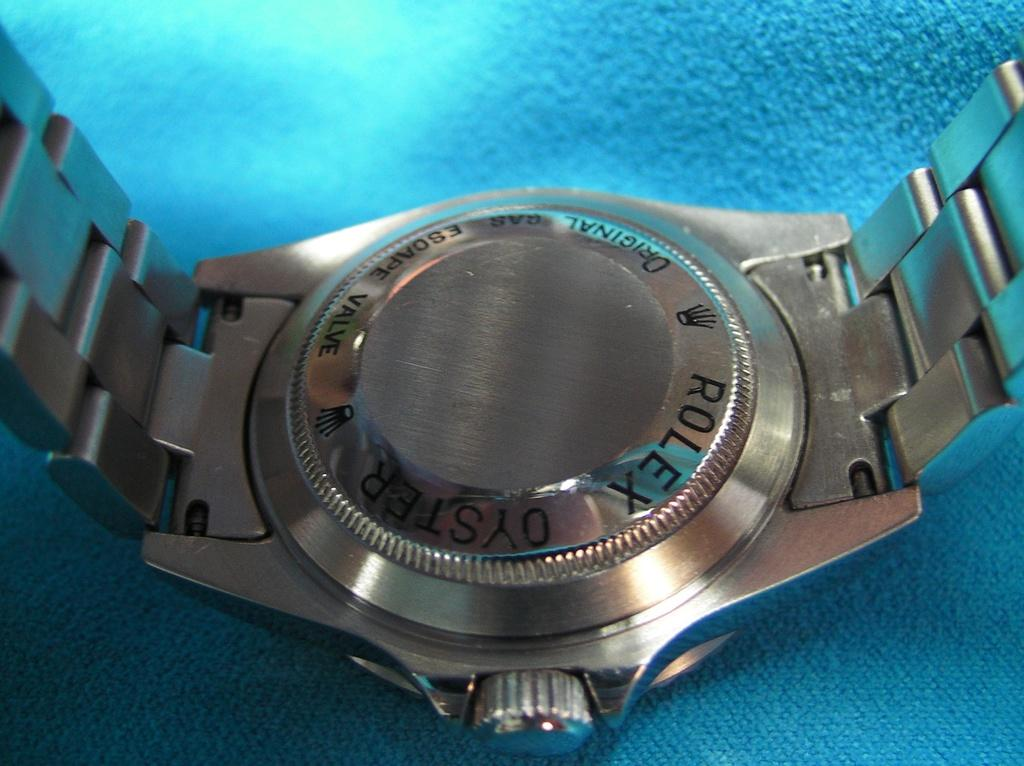<image>
Describe the image concisely. The back of a silver Rolex Oyster watch. 